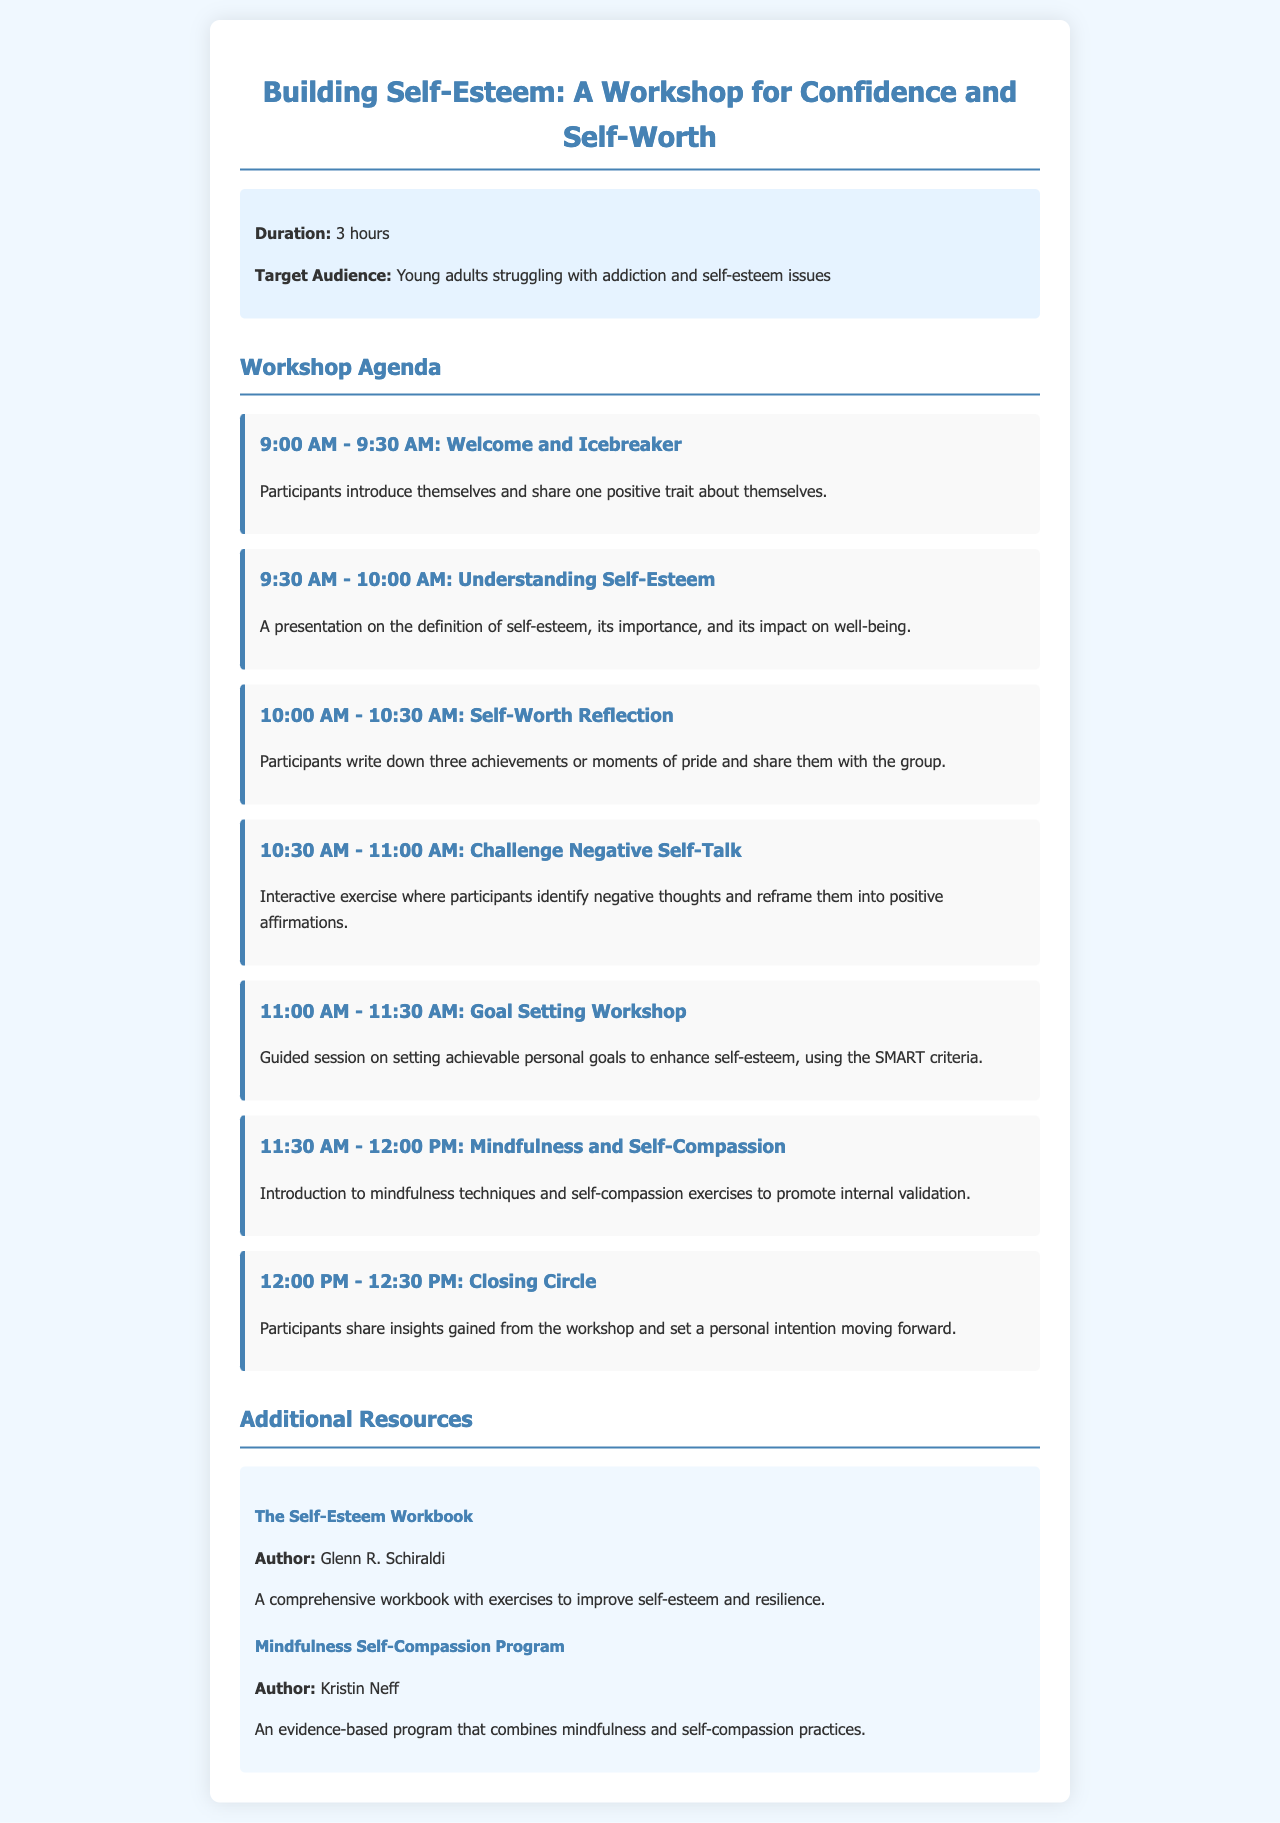What is the duration of the workshop? The duration is specified in the information section of the document, which states it is 3 hours.
Answer: 3 hours Who is the target audience for the workshop? The document outlines the target audience in the info section, indicating it is young adults struggling with addiction and self-esteem issues.
Answer: Young adults struggling with addiction and self-esteem issues What time does the Welcome and Icebreaker start? The agenda item for Welcome and Icebreaker states the starting time as 9:00 AM.
Answer: 9:00 AM What exercise is included to challenge negative self-talk? The agenda item outlines that the exercise is an interactive exercise that involves identifying negative thoughts and reframing them into positive affirmations.
Answer: Challenge Negative Self-Talk How many achievements do participants write down during the Self-Worth Reflection? The document mentions that participants write down three achievements or moments of pride.
Answer: Three achievements What criteria is used in the Goal Setting Workshop? The agenda specifies that the SMART criteria are used in the Goal Setting Workshop.
Answer: SMART criteria Which author wrote "The Self-Esteem Workbook"? The resource section lists the author of "The Self-Esteem Workbook" as Glenn R. Schiraldi.
Answer: Glenn R. Schiraldi What is the final activity of the workshop? The closing activity listed in the agenda is the Closing Circle, where participants share insights and set a personal intention.
Answer: Closing Circle 